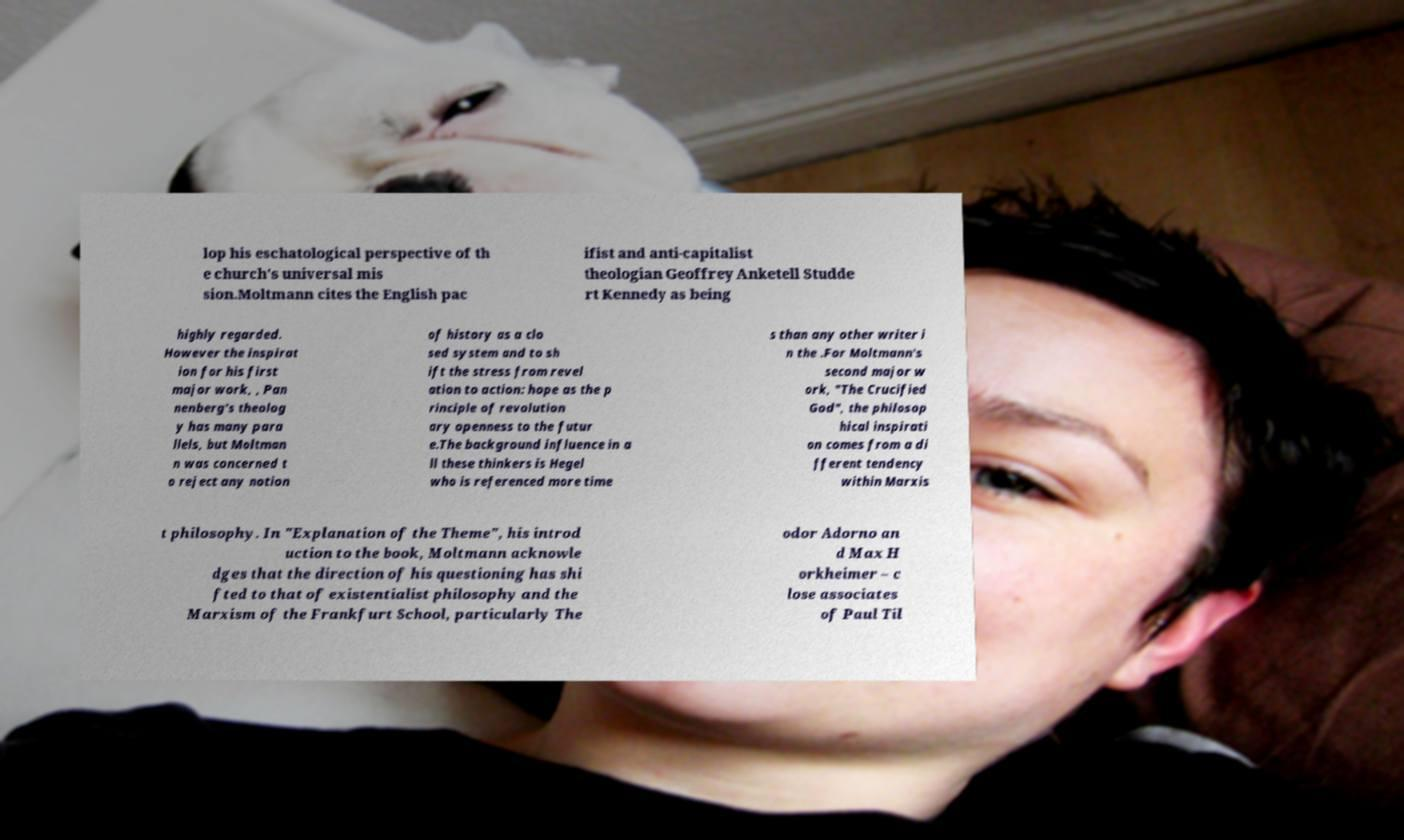Could you assist in decoding the text presented in this image and type it out clearly? lop his eschatological perspective of th e church's universal mis sion.Moltmann cites the English pac ifist and anti-capitalist theologian Geoffrey Anketell Studde rt Kennedy as being highly regarded. However the inspirat ion for his first major work, , Pan nenberg's theolog y has many para llels, but Moltman n was concerned t o reject any notion of history as a clo sed system and to sh ift the stress from revel ation to action: hope as the p rinciple of revolution ary openness to the futur e.The background influence in a ll these thinkers is Hegel who is referenced more time s than any other writer i n the .For Moltmann's second major w ork, "The Crucified God", the philosop hical inspirati on comes from a di fferent tendency within Marxis t philosophy. In "Explanation of the Theme", his introd uction to the book, Moltmann acknowle dges that the direction of his questioning has shi fted to that of existentialist philosophy and the Marxism of the Frankfurt School, particularly The odor Adorno an d Max H orkheimer – c lose associates of Paul Til 